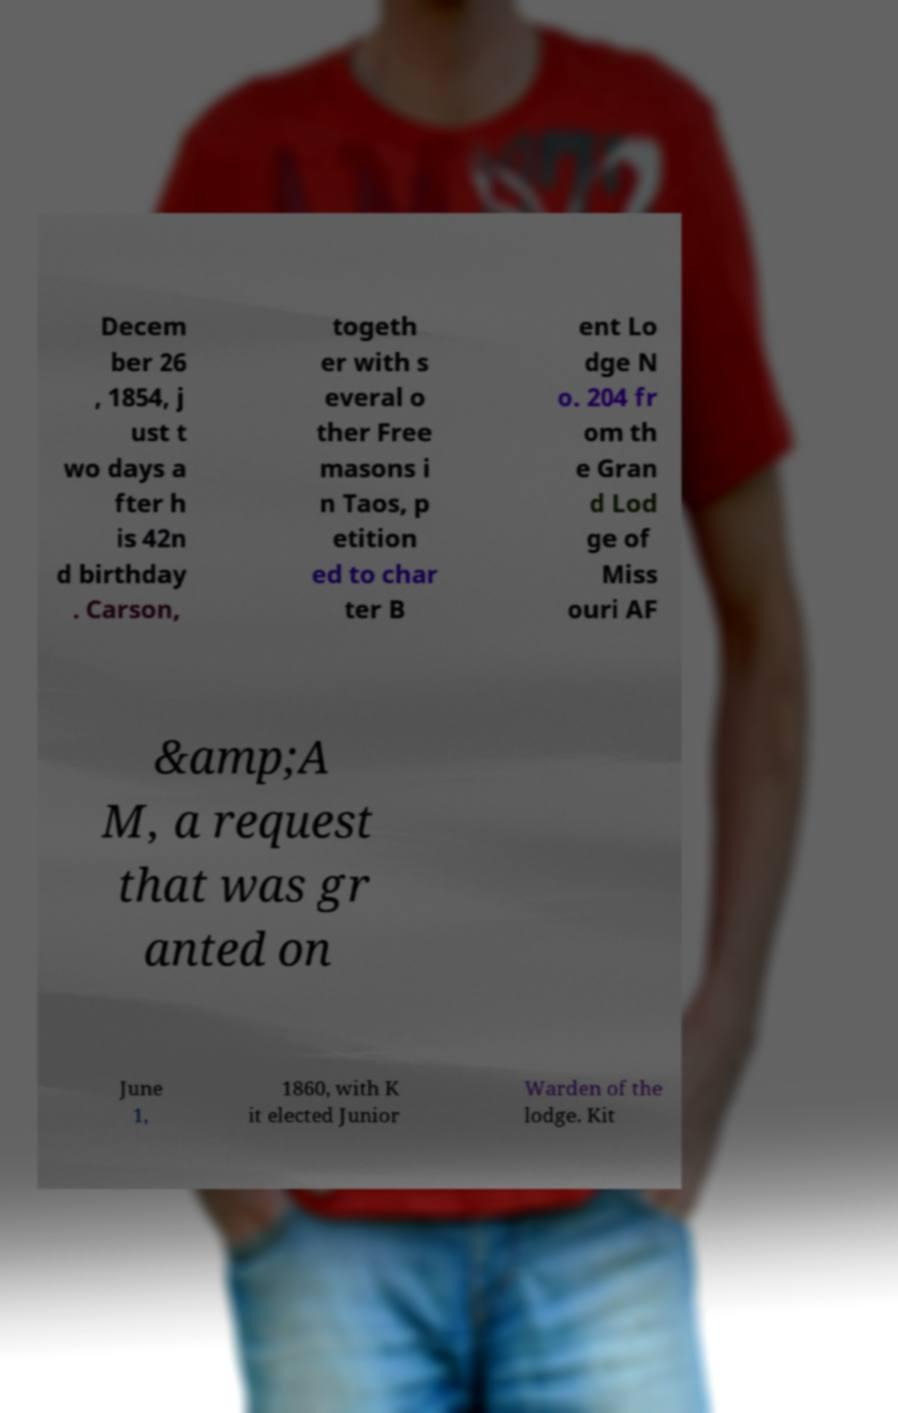Please identify and transcribe the text found in this image. Decem ber 26 , 1854, j ust t wo days a fter h is 42n d birthday . Carson, togeth er with s everal o ther Free masons i n Taos, p etition ed to char ter B ent Lo dge N o. 204 fr om th e Gran d Lod ge of Miss ouri AF &amp;A M, a request that was gr anted on June 1, 1860, with K it elected Junior Warden of the lodge. Kit 